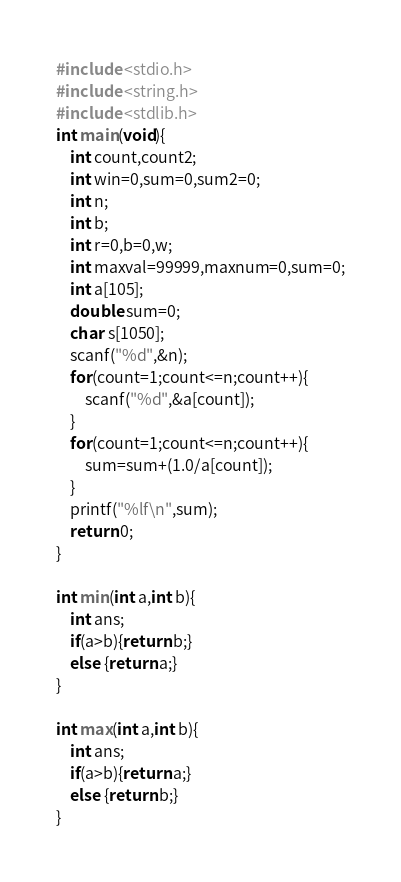Convert code to text. <code><loc_0><loc_0><loc_500><loc_500><_C_>#include <stdio.h>
#include <string.h>
#include <stdlib.h>
int main(void){
    int count,count2;
    int win=0,sum=0,sum2=0;
    int n;
    int b;
    int r=0,b=0,w;
    int maxval=99999,maxnum=0,sum=0;
    int a[105];
    double sum=0;
    char s[1050];
    scanf("%d",&n);
    for(count=1;count<=n;count++){
        scanf("%d",&a[count]);
    }
    for(count=1;count<=n;count++){
        sum=sum+(1.0/a[count]);
    }
    printf("%lf\n",sum);
    return 0;
}
 
int min(int a,int b){
    int ans;
    if(a>b){return b;}
    else {return a;}
}
 
int max(int a,int b){
    int ans;
    if(a>b){return a;}
    else {return b;}
}
</code> 